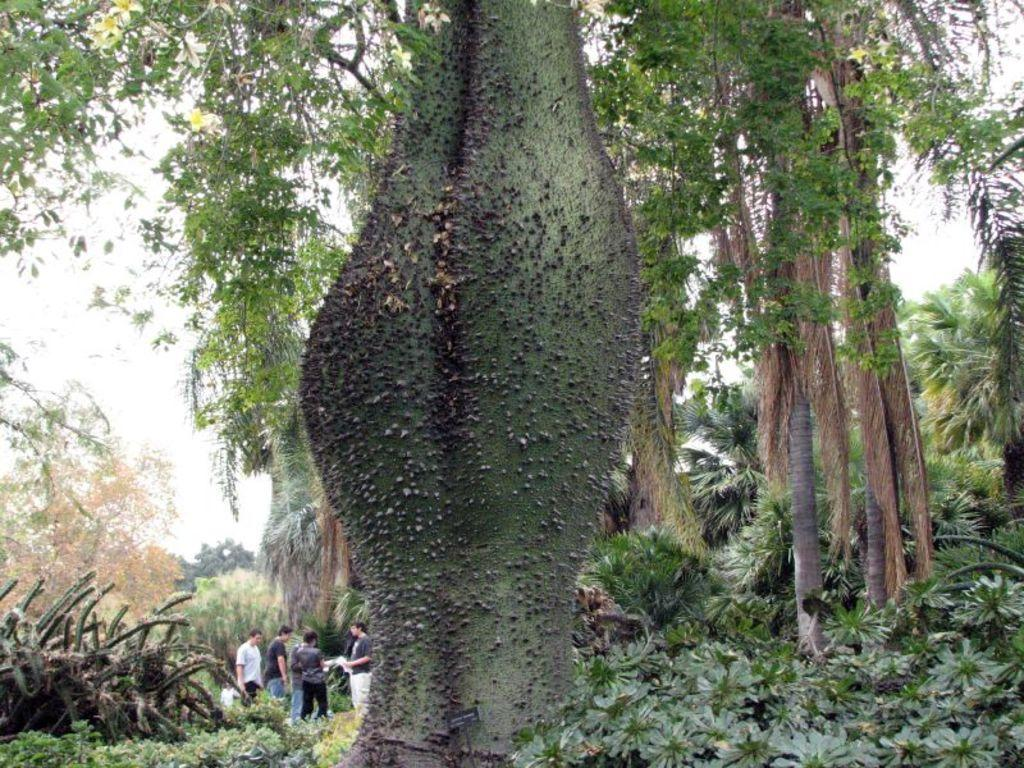What type of vegetation can be seen in the image? There are trees, plants, and flowers in the image. What else is present in the image besides vegetation? There is a group of people standing in the image. What can be seen in the background of the image? The sky is visible in the background of the image. What type of engine can be seen powering the flowers in the image? There is no engine present in the image, and flowers do not require engines to function. 